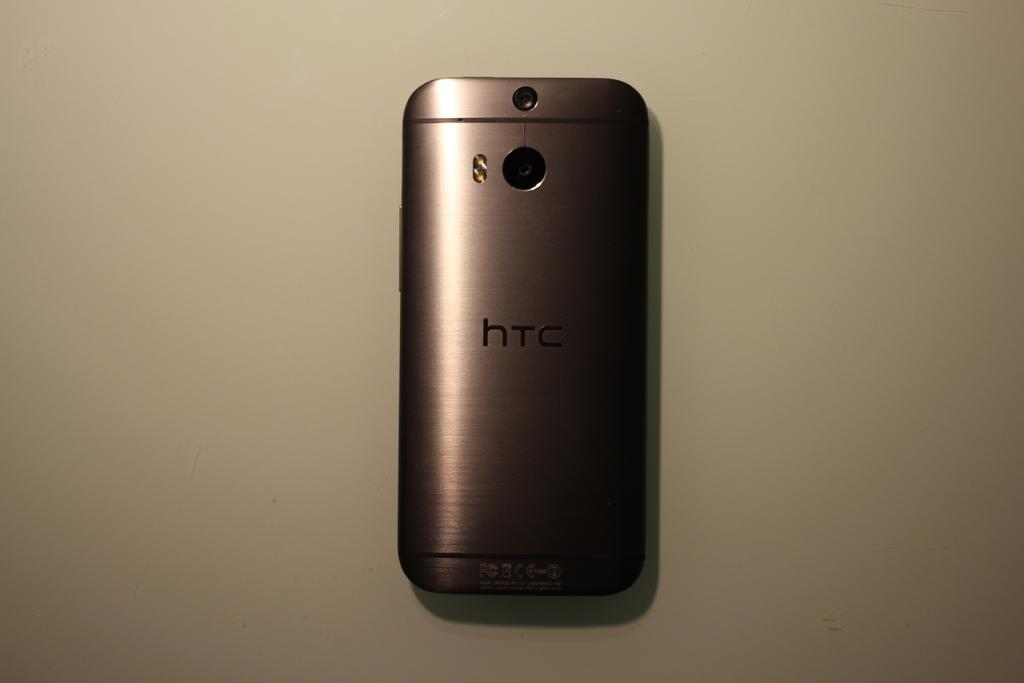<image>
Give a short and clear explanation of the subsequent image. A silver htc phone is on a white surface. 